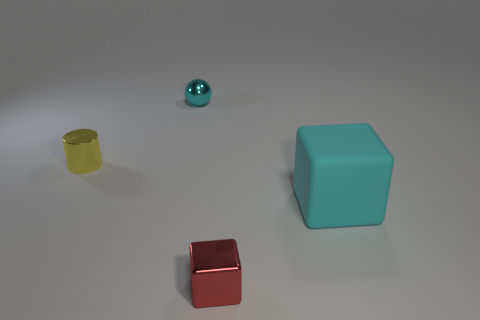Add 1 rubber objects. How many objects exist? 5 Subtract all tiny red metallic things. Subtract all small cylinders. How many objects are left? 2 Add 1 red things. How many red things are left? 2 Add 4 tiny yellow rubber things. How many tiny yellow rubber things exist? 4 Subtract 0 yellow cubes. How many objects are left? 4 Subtract all gray blocks. Subtract all cyan cylinders. How many blocks are left? 2 Subtract all purple balls. How many blue cubes are left? 0 